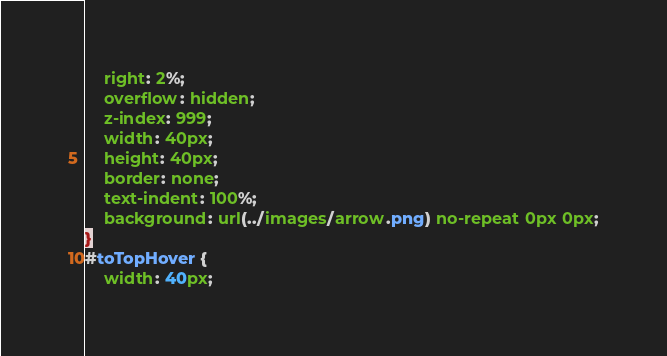<code> <loc_0><loc_0><loc_500><loc_500><_CSS_>	right: 2%;
	overflow: hidden;
	z-index: 999; 
	width: 40px;
	height: 40px;
	border: none;
	text-indent: 100%;
	background: url(../images/arrow.png) no-repeat 0px 0px;
}
#toTopHover {
	width: 40px;</code> 